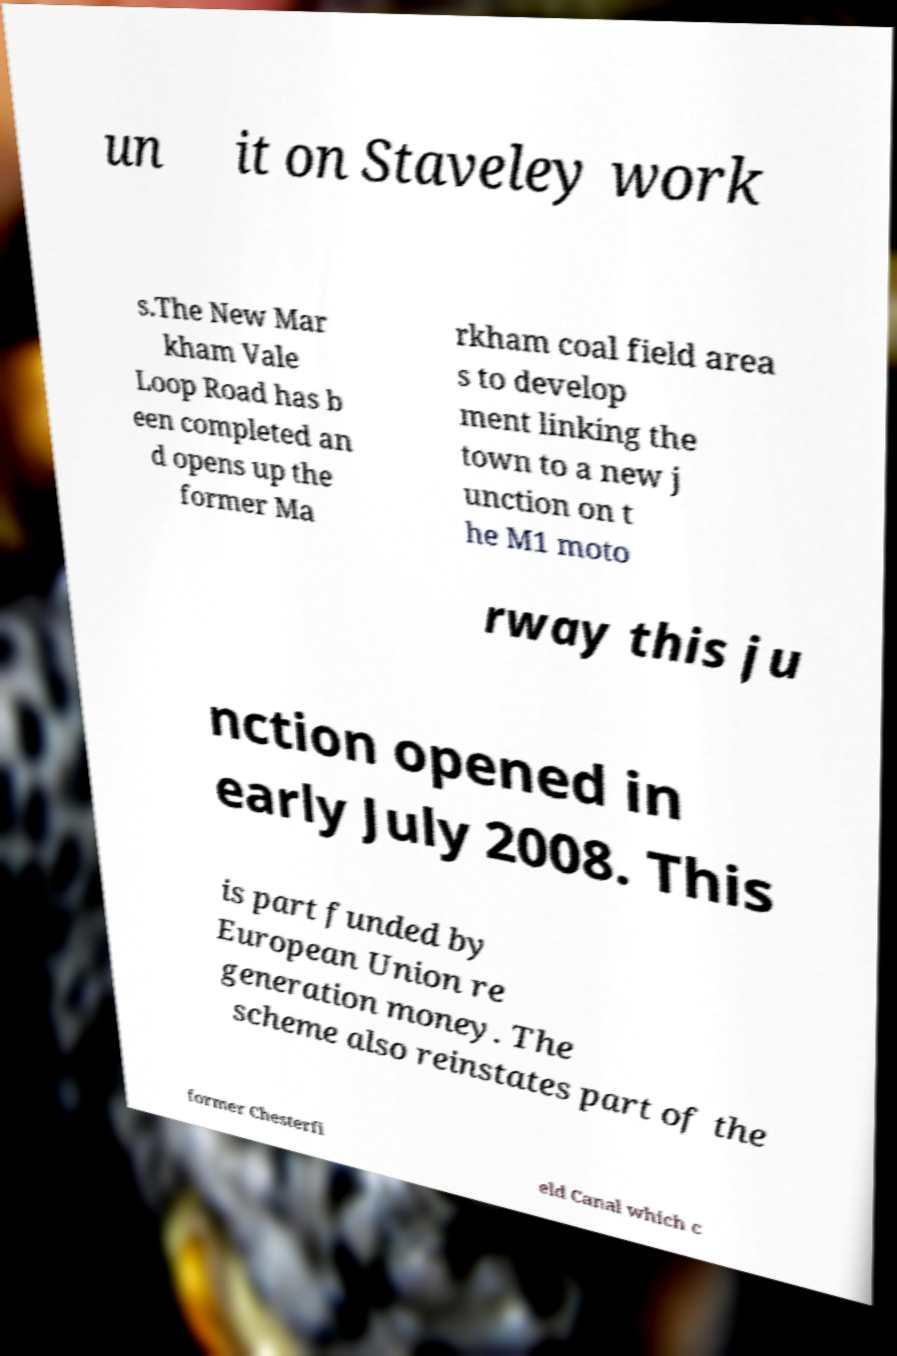Please read and relay the text visible in this image. What does it say? un it on Staveley work s.The New Mar kham Vale Loop Road has b een completed an d opens up the former Ma rkham coal field area s to develop ment linking the town to a new j unction on t he M1 moto rway this ju nction opened in early July 2008. This is part funded by European Union re generation money. The scheme also reinstates part of the former Chesterfi eld Canal which c 